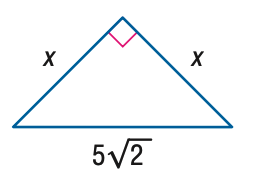Question: Find x.
Choices:
A. \frac { 5 } { 2 } \sqrt { 2 }
B. 5
C. 5 \sqrt { 2 }
D. 10
Answer with the letter. Answer: B 